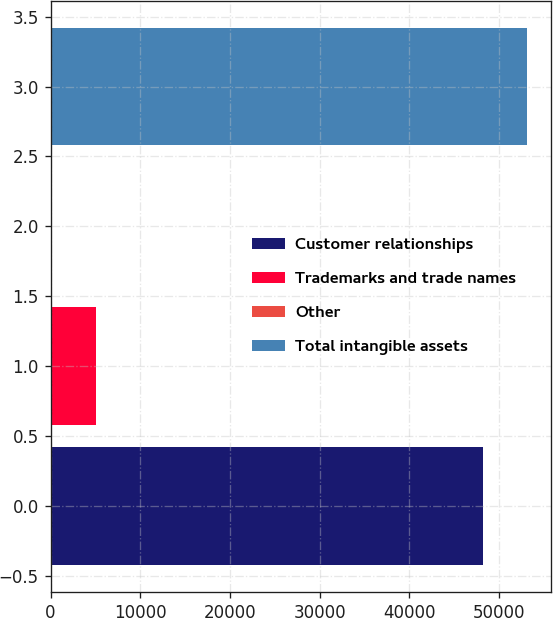Convert chart to OTSL. <chart><loc_0><loc_0><loc_500><loc_500><bar_chart><fcel>Customer relationships<fcel>Trademarks and trade names<fcel>Other<fcel>Total intangible assets<nl><fcel>48261<fcel>5123.1<fcel>220<fcel>53164.1<nl></chart> 